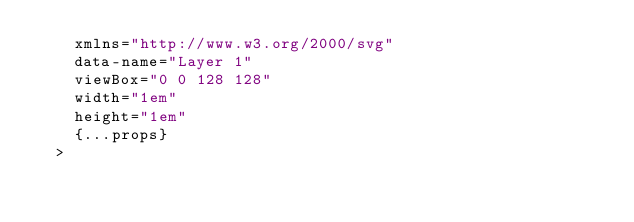Convert code to text. <code><loc_0><loc_0><loc_500><loc_500><_TypeScript_>    xmlns="http://www.w3.org/2000/svg"
    data-name="Layer 1"
    viewBox="0 0 128 128"
    width="1em"
    height="1em"
    {...props}
  ></code> 